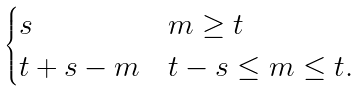Convert formula to latex. <formula><loc_0><loc_0><loc_500><loc_500>\begin{cases} s & m \geq t \\ t + s - m & t - s \leq m \leq t . \end{cases}</formula> 